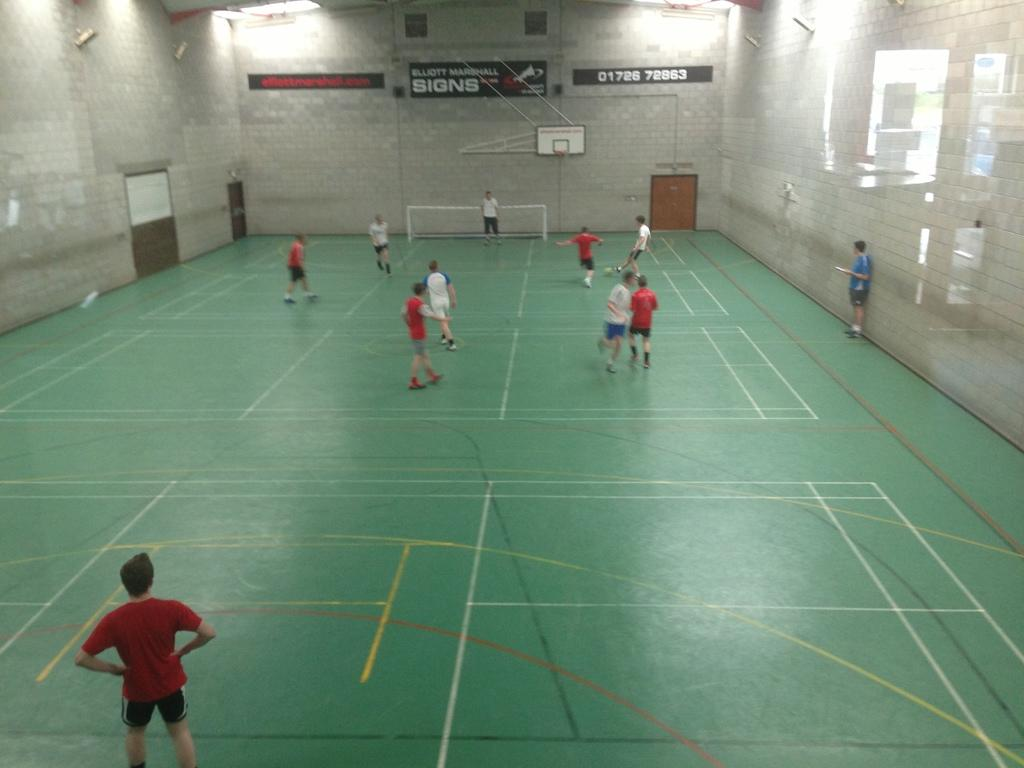<image>
Create a compact narrative representing the image presented. A gymnasium has a black sign that says Elliott Marshall Signs on it. 